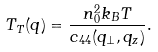<formula> <loc_0><loc_0><loc_500><loc_500>T _ { T } ( { q } ) = \frac { n _ { 0 } ^ { 2 } { k _ { B } } T } { c _ { 4 4 } ( q _ { \perp } , q _ { z } ) } .</formula> 